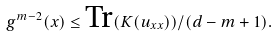Convert formula to latex. <formula><loc_0><loc_0><loc_500><loc_500>g ^ { m - 2 } ( x ) \leq \text {Tr} ( K ( u _ { x x } ) ) / ( d - m + 1 ) .</formula> 